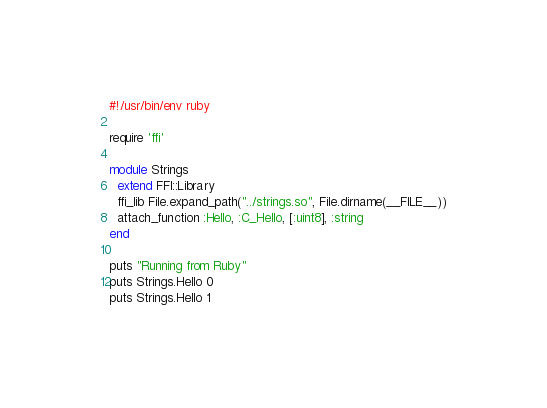Convert code to text. <code><loc_0><loc_0><loc_500><loc_500><_Ruby_>#!/usr/bin/env ruby

require 'ffi'

module Strings
  extend FFI::Library
  ffi_lib File.expand_path("../strings.so", File.dirname(__FILE__))
  attach_function :Hello, :C_Hello, [:uint8], :string
end

puts "Running from Ruby"
puts Strings.Hello 0
puts Strings.Hello 1
</code> 